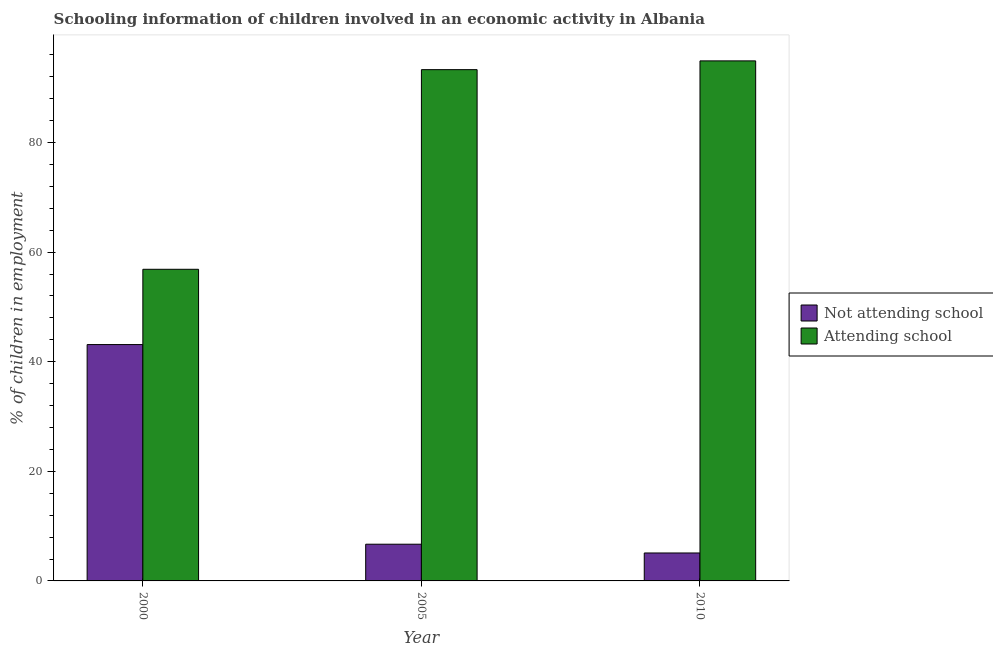How many different coloured bars are there?
Your response must be concise. 2. Are the number of bars per tick equal to the number of legend labels?
Your answer should be very brief. Yes. Are the number of bars on each tick of the X-axis equal?
Keep it short and to the point. Yes. What is the label of the 2nd group of bars from the left?
Make the answer very short. 2005. What is the percentage of employed children who are attending school in 2005?
Your answer should be very brief. 93.3. Across all years, what is the maximum percentage of employed children who are not attending school?
Provide a short and direct response. 43.13. Across all years, what is the minimum percentage of employed children who are attending school?
Your answer should be compact. 56.87. In which year was the percentage of employed children who are attending school maximum?
Provide a succinct answer. 2010. What is the total percentage of employed children who are not attending school in the graph?
Offer a very short reply. 54.93. What is the difference between the percentage of employed children who are not attending school in 2000 and that in 2010?
Your response must be concise. 38.03. What is the difference between the percentage of employed children who are attending school in 2005 and the percentage of employed children who are not attending school in 2000?
Make the answer very short. 36.43. What is the average percentage of employed children who are attending school per year?
Your answer should be very brief. 81.69. In the year 2010, what is the difference between the percentage of employed children who are attending school and percentage of employed children who are not attending school?
Your answer should be compact. 0. In how many years, is the percentage of employed children who are not attending school greater than 12 %?
Your response must be concise. 1. What is the ratio of the percentage of employed children who are not attending school in 2005 to that in 2010?
Offer a very short reply. 1.31. What is the difference between the highest and the second highest percentage of employed children who are attending school?
Your response must be concise. 1.6. What is the difference between the highest and the lowest percentage of employed children who are not attending school?
Ensure brevity in your answer.  38.03. In how many years, is the percentage of employed children who are not attending school greater than the average percentage of employed children who are not attending school taken over all years?
Your answer should be very brief. 1. What does the 1st bar from the left in 2010 represents?
Make the answer very short. Not attending school. What does the 1st bar from the right in 2000 represents?
Your answer should be very brief. Attending school. How many bars are there?
Your response must be concise. 6. Are all the bars in the graph horizontal?
Offer a terse response. No. How many years are there in the graph?
Give a very brief answer. 3. What is the difference between two consecutive major ticks on the Y-axis?
Your answer should be very brief. 20. Does the graph contain grids?
Offer a very short reply. No. How many legend labels are there?
Your response must be concise. 2. How are the legend labels stacked?
Your answer should be very brief. Vertical. What is the title of the graph?
Make the answer very short. Schooling information of children involved in an economic activity in Albania. Does "Diesel" appear as one of the legend labels in the graph?
Your answer should be very brief. No. What is the label or title of the Y-axis?
Your response must be concise. % of children in employment. What is the % of children in employment of Not attending school in 2000?
Give a very brief answer. 43.13. What is the % of children in employment of Attending school in 2000?
Your answer should be very brief. 56.87. What is the % of children in employment in Not attending school in 2005?
Provide a short and direct response. 6.7. What is the % of children in employment of Attending school in 2005?
Your answer should be compact. 93.3. What is the % of children in employment of Not attending school in 2010?
Offer a very short reply. 5.1. What is the % of children in employment of Attending school in 2010?
Provide a succinct answer. 94.9. Across all years, what is the maximum % of children in employment of Not attending school?
Give a very brief answer. 43.13. Across all years, what is the maximum % of children in employment in Attending school?
Give a very brief answer. 94.9. Across all years, what is the minimum % of children in employment of Not attending school?
Give a very brief answer. 5.1. Across all years, what is the minimum % of children in employment of Attending school?
Provide a succinct answer. 56.87. What is the total % of children in employment in Not attending school in the graph?
Provide a short and direct response. 54.93. What is the total % of children in employment in Attending school in the graph?
Your answer should be very brief. 245.07. What is the difference between the % of children in employment of Not attending school in 2000 and that in 2005?
Provide a short and direct response. 36.43. What is the difference between the % of children in employment in Attending school in 2000 and that in 2005?
Offer a terse response. -36.43. What is the difference between the % of children in employment in Not attending school in 2000 and that in 2010?
Your answer should be compact. 38.03. What is the difference between the % of children in employment of Attending school in 2000 and that in 2010?
Your answer should be compact. -38.03. What is the difference between the % of children in employment of Not attending school in 2005 and that in 2010?
Provide a short and direct response. 1.6. What is the difference between the % of children in employment of Attending school in 2005 and that in 2010?
Offer a very short reply. -1.6. What is the difference between the % of children in employment of Not attending school in 2000 and the % of children in employment of Attending school in 2005?
Give a very brief answer. -50.17. What is the difference between the % of children in employment of Not attending school in 2000 and the % of children in employment of Attending school in 2010?
Provide a succinct answer. -51.77. What is the difference between the % of children in employment in Not attending school in 2005 and the % of children in employment in Attending school in 2010?
Make the answer very short. -88.2. What is the average % of children in employment in Not attending school per year?
Your response must be concise. 18.31. What is the average % of children in employment in Attending school per year?
Keep it short and to the point. 81.69. In the year 2000, what is the difference between the % of children in employment in Not attending school and % of children in employment in Attending school?
Make the answer very short. -13.74. In the year 2005, what is the difference between the % of children in employment in Not attending school and % of children in employment in Attending school?
Your answer should be compact. -86.6. In the year 2010, what is the difference between the % of children in employment of Not attending school and % of children in employment of Attending school?
Your answer should be compact. -89.8. What is the ratio of the % of children in employment in Not attending school in 2000 to that in 2005?
Offer a terse response. 6.44. What is the ratio of the % of children in employment in Attending school in 2000 to that in 2005?
Offer a terse response. 0.61. What is the ratio of the % of children in employment in Not attending school in 2000 to that in 2010?
Your answer should be very brief. 8.46. What is the ratio of the % of children in employment in Attending school in 2000 to that in 2010?
Your response must be concise. 0.6. What is the ratio of the % of children in employment of Not attending school in 2005 to that in 2010?
Your answer should be compact. 1.31. What is the ratio of the % of children in employment of Attending school in 2005 to that in 2010?
Provide a succinct answer. 0.98. What is the difference between the highest and the second highest % of children in employment in Not attending school?
Your response must be concise. 36.43. What is the difference between the highest and the lowest % of children in employment in Not attending school?
Your answer should be very brief. 38.03. What is the difference between the highest and the lowest % of children in employment in Attending school?
Make the answer very short. 38.03. 